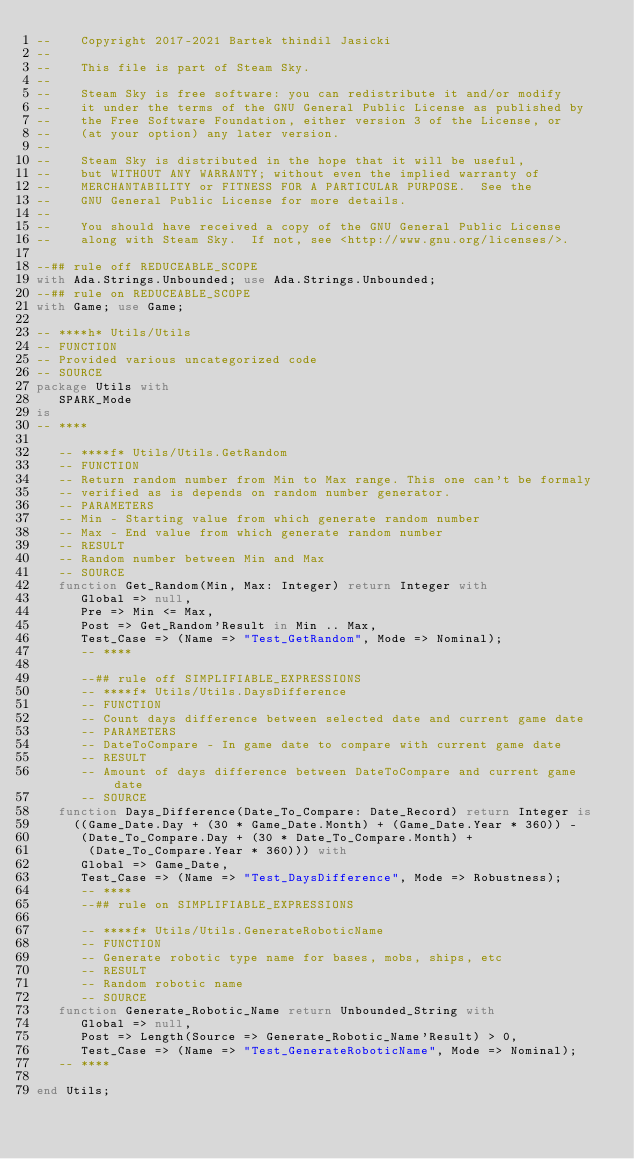Convert code to text. <code><loc_0><loc_0><loc_500><loc_500><_Ada_>--    Copyright 2017-2021 Bartek thindil Jasicki
--
--    This file is part of Steam Sky.
--
--    Steam Sky is free software: you can redistribute it and/or modify
--    it under the terms of the GNU General Public License as published by
--    the Free Software Foundation, either version 3 of the License, or
--    (at your option) any later version.
--
--    Steam Sky is distributed in the hope that it will be useful,
--    but WITHOUT ANY WARRANTY; without even the implied warranty of
--    MERCHANTABILITY or FITNESS FOR A PARTICULAR PURPOSE.  See the
--    GNU General Public License for more details.
--
--    You should have received a copy of the GNU General Public License
--    along with Steam Sky.  If not, see <http://www.gnu.org/licenses/>.

--## rule off REDUCEABLE_SCOPE
with Ada.Strings.Unbounded; use Ada.Strings.Unbounded;
--## rule on REDUCEABLE_SCOPE
with Game; use Game;

-- ****h* Utils/Utils
-- FUNCTION
-- Provided various uncategorized code
-- SOURCE
package Utils with
   SPARK_Mode
is
-- ****

   -- ****f* Utils/Utils.GetRandom
   -- FUNCTION
   -- Return random number from Min to Max range. This one can't be formaly
   -- verified as is depends on random number generator.
   -- PARAMETERS
   -- Min - Starting value from which generate random number
   -- Max - End value from which generate random number
   -- RESULT
   -- Random number between Min and Max
   -- SOURCE
   function Get_Random(Min, Max: Integer) return Integer with
      Global => null,
      Pre => Min <= Max,
      Post => Get_Random'Result in Min .. Max,
      Test_Case => (Name => "Test_GetRandom", Mode => Nominal);
      -- ****

      --## rule off SIMPLIFIABLE_EXPRESSIONS
      -- ****f* Utils/Utils.DaysDifference
      -- FUNCTION
      -- Count days difference between selected date and current game date
      -- PARAMETERS
      -- DateToCompare - In game date to compare with current game date
      -- RESULT
      -- Amount of days difference between DateToCompare and current game date
      -- SOURCE
   function Days_Difference(Date_To_Compare: Date_Record) return Integer is
     ((Game_Date.Day + (30 * Game_Date.Month) + (Game_Date.Year * 360)) -
      (Date_To_Compare.Day + (30 * Date_To_Compare.Month) +
       (Date_To_Compare.Year * 360))) with
      Global => Game_Date,
      Test_Case => (Name => "Test_DaysDifference", Mode => Robustness);
      -- ****
      --## rule on SIMPLIFIABLE_EXPRESSIONS

      -- ****f* Utils/Utils.GenerateRoboticName
      -- FUNCTION
      -- Generate robotic type name for bases, mobs, ships, etc
      -- RESULT
      -- Random robotic name
      -- SOURCE
   function Generate_Robotic_Name return Unbounded_String with
      Global => null,
      Post => Length(Source => Generate_Robotic_Name'Result) > 0,
      Test_Case => (Name => "Test_GenerateRoboticName", Mode => Nominal);
   -- ****

end Utils;
</code> 